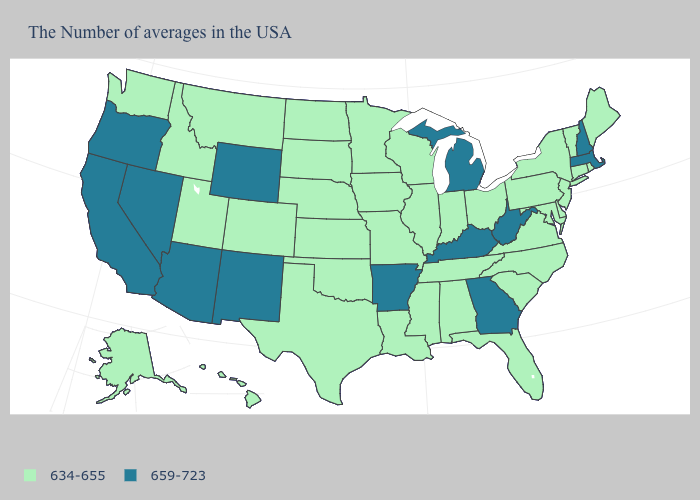Which states have the highest value in the USA?
Keep it brief. Massachusetts, New Hampshire, West Virginia, Georgia, Michigan, Kentucky, Arkansas, Wyoming, New Mexico, Arizona, Nevada, California, Oregon. Which states have the highest value in the USA?
Concise answer only. Massachusetts, New Hampshire, West Virginia, Georgia, Michigan, Kentucky, Arkansas, Wyoming, New Mexico, Arizona, Nevada, California, Oregon. Does New Jersey have the same value as Montana?
Give a very brief answer. Yes. What is the value of Utah?
Quick response, please. 634-655. Among the states that border Rhode Island , which have the highest value?
Short answer required. Massachusetts. What is the value of New Mexico?
Keep it brief. 659-723. Among the states that border Indiana , which have the lowest value?
Give a very brief answer. Ohio, Illinois. What is the value of Texas?
Short answer required. 634-655. Name the states that have a value in the range 634-655?
Answer briefly. Maine, Rhode Island, Vermont, Connecticut, New York, New Jersey, Delaware, Maryland, Pennsylvania, Virginia, North Carolina, South Carolina, Ohio, Florida, Indiana, Alabama, Tennessee, Wisconsin, Illinois, Mississippi, Louisiana, Missouri, Minnesota, Iowa, Kansas, Nebraska, Oklahoma, Texas, South Dakota, North Dakota, Colorado, Utah, Montana, Idaho, Washington, Alaska, Hawaii. Among the states that border Massachusetts , which have the lowest value?
Answer briefly. Rhode Island, Vermont, Connecticut, New York. Among the states that border Montana , which have the lowest value?
Answer briefly. South Dakota, North Dakota, Idaho. Does the first symbol in the legend represent the smallest category?
Write a very short answer. Yes. Among the states that border Kentucky , does Indiana have the highest value?
Short answer required. No. What is the value of Virginia?
Give a very brief answer. 634-655. What is the highest value in states that border Montana?
Short answer required. 659-723. 